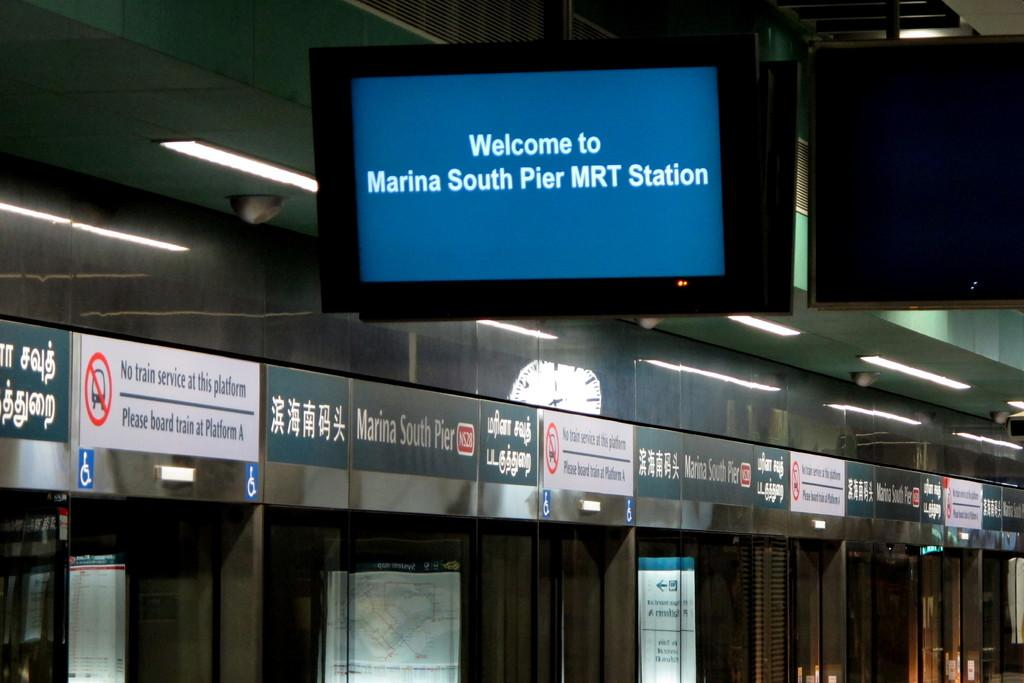<image>
Create a compact narrative representing the image presented. The screen in the terminal says, 'Welcome to Marina South Pier MRT Station'. 